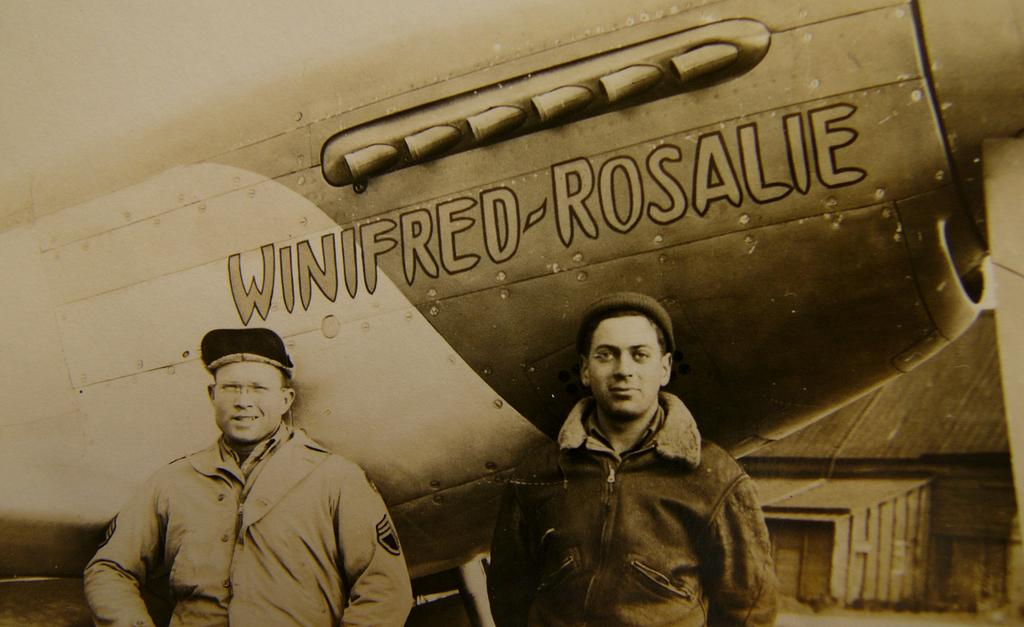What is the color scheme of the image? The image is black and white. How many people are in the image? There are two people standing in the image. What are the people doing in the image? The people are posing for a photo. What can be seen in the background of the image? There is an object in the background that resembles an aircraft. What type of stitch is being used to sew the coast in the image? There is no coast or stitching present in the image; it is a black and white photo of two people posing with an object that resembles an aircraft in the background. 